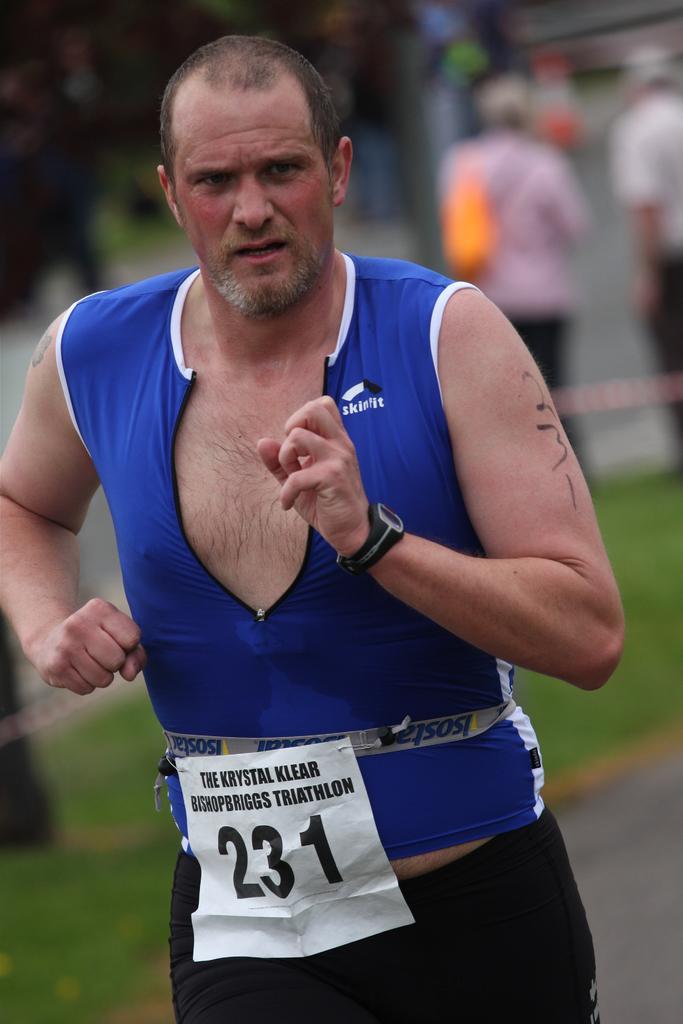How would you summarize this image in a sentence or two? In the picture we can see a man running on the road and wearing a blue color top and a number to it 231 and behind him we can see some grass surface and near it we can see some people are walking. 